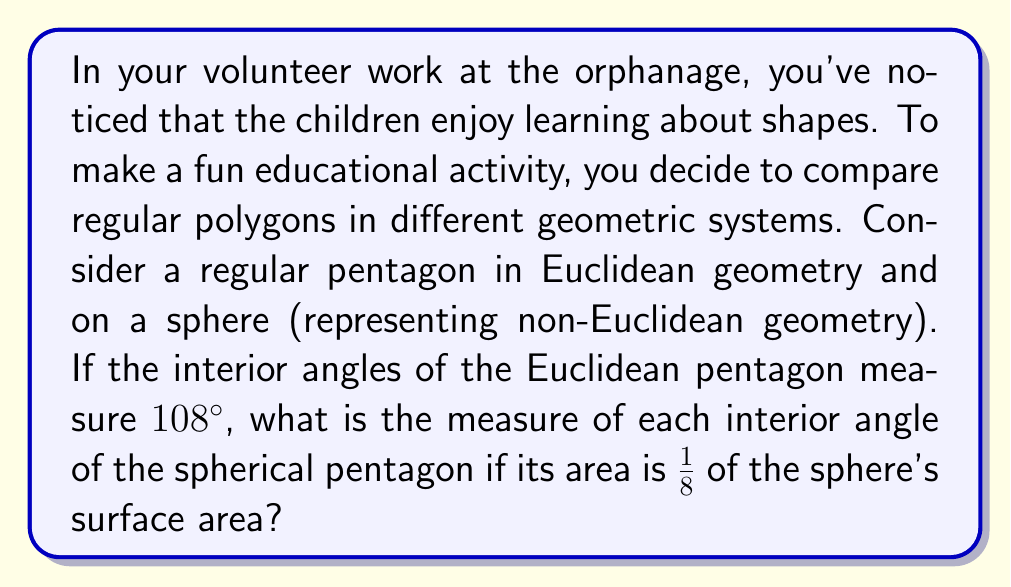Provide a solution to this math problem. Let's approach this step-by-step:

1) In Euclidean geometry, the sum of interior angles of a pentagon is given by the formula:
   $$(n-2) \times 180°$$
   where $n$ is the number of sides. For a pentagon, $n=5$, so:
   $$(5-2) \times 180° = 540°$$

2) Each interior angle of a regular Euclidean pentagon measures:
   $$\frac{540°}{5} = 108°$$

3) On a sphere (non-Euclidean geometry), the sum of interior angles of a pentagon is greater than 540°. The excess is proportional to the area of the pentagon.

4) The excess $E$ is given by:
   $$E = A \times \frac{720°}{\text{surface area of sphere}}$$
   where $A$ is the area of the pentagon.

5) We're told the pentagon's area is 1/8 of the sphere's surface area, so:
   $$E = \frac{1}{8} \times 720° = 90°$$

6) Therefore, the sum of interior angles of the spherical pentagon is:
   $$540° + 90° = 630°$$

7) For a regular pentagon, each interior angle measures:
   $$\frac{630°}{5} = 126°$$

Thus, each interior angle of the spherical pentagon measures 126°.
Answer: 126° 